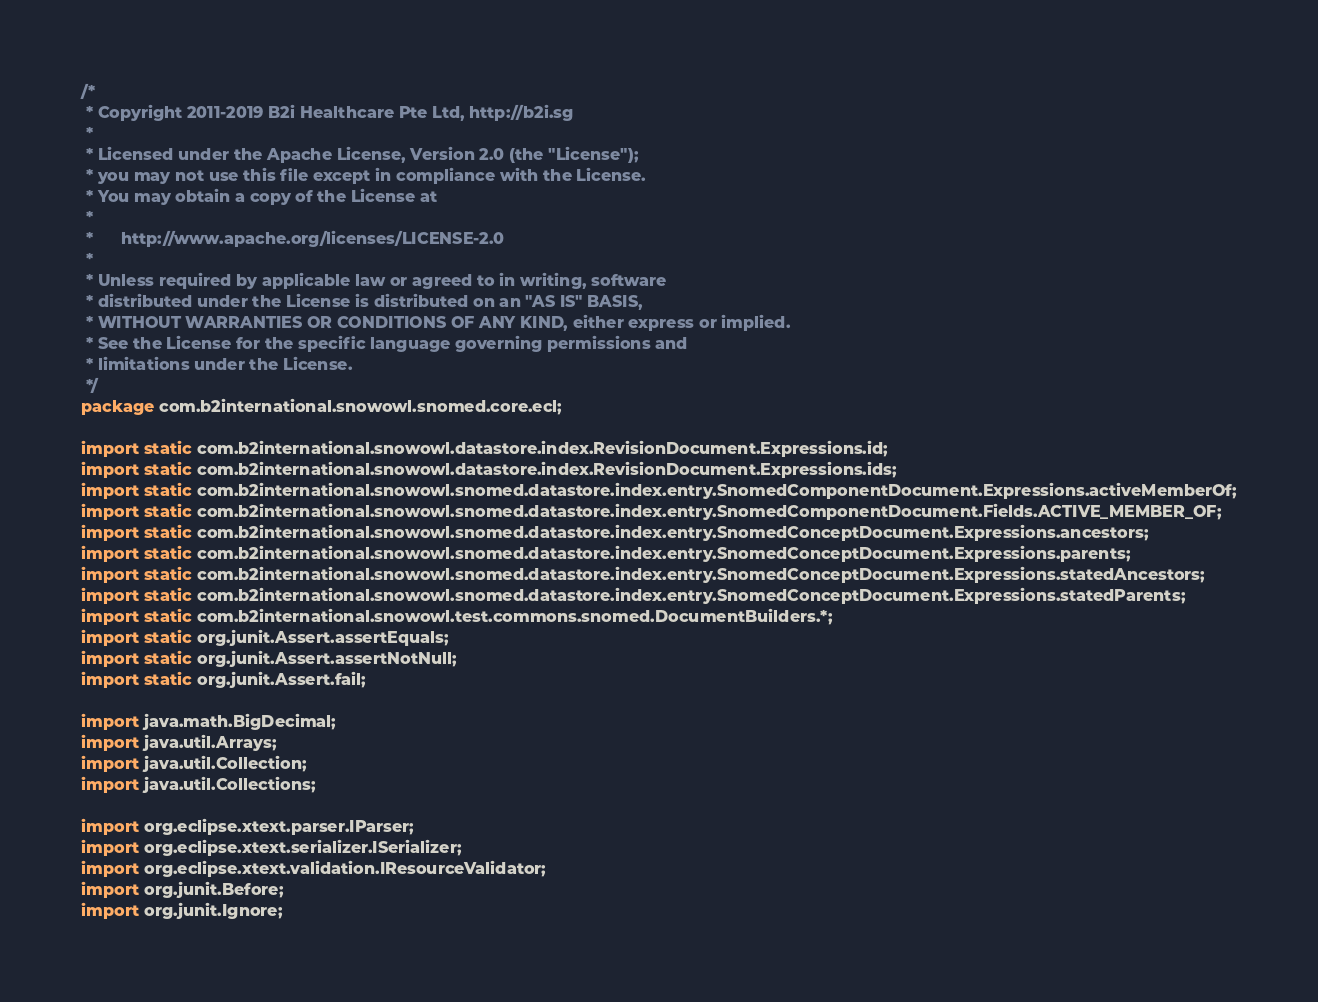<code> <loc_0><loc_0><loc_500><loc_500><_Java_>/*
 * Copyright 2011-2019 B2i Healthcare Pte Ltd, http://b2i.sg
 * 
 * Licensed under the Apache License, Version 2.0 (the "License");
 * you may not use this file except in compliance with the License.
 * You may obtain a copy of the License at
 *
 *      http://www.apache.org/licenses/LICENSE-2.0
 *
 * Unless required by applicable law or agreed to in writing, software
 * distributed under the License is distributed on an "AS IS" BASIS,
 * WITHOUT WARRANTIES OR CONDITIONS OF ANY KIND, either express or implied.
 * See the License for the specific language governing permissions and
 * limitations under the License.
 */
package com.b2international.snowowl.snomed.core.ecl;

import static com.b2international.snowowl.datastore.index.RevisionDocument.Expressions.id;
import static com.b2international.snowowl.datastore.index.RevisionDocument.Expressions.ids;
import static com.b2international.snowowl.snomed.datastore.index.entry.SnomedComponentDocument.Expressions.activeMemberOf;
import static com.b2international.snowowl.snomed.datastore.index.entry.SnomedComponentDocument.Fields.ACTIVE_MEMBER_OF;
import static com.b2international.snowowl.snomed.datastore.index.entry.SnomedConceptDocument.Expressions.ancestors;
import static com.b2international.snowowl.snomed.datastore.index.entry.SnomedConceptDocument.Expressions.parents;
import static com.b2international.snowowl.snomed.datastore.index.entry.SnomedConceptDocument.Expressions.statedAncestors;
import static com.b2international.snowowl.snomed.datastore.index.entry.SnomedConceptDocument.Expressions.statedParents;
import static com.b2international.snowowl.test.commons.snomed.DocumentBuilders.*;
import static org.junit.Assert.assertEquals;
import static org.junit.Assert.assertNotNull;
import static org.junit.Assert.fail;

import java.math.BigDecimal;
import java.util.Arrays;
import java.util.Collection;
import java.util.Collections;

import org.eclipse.xtext.parser.IParser;
import org.eclipse.xtext.serializer.ISerializer;
import org.eclipse.xtext.validation.IResourceValidator;
import org.junit.Before;
import org.junit.Ignore;</code> 